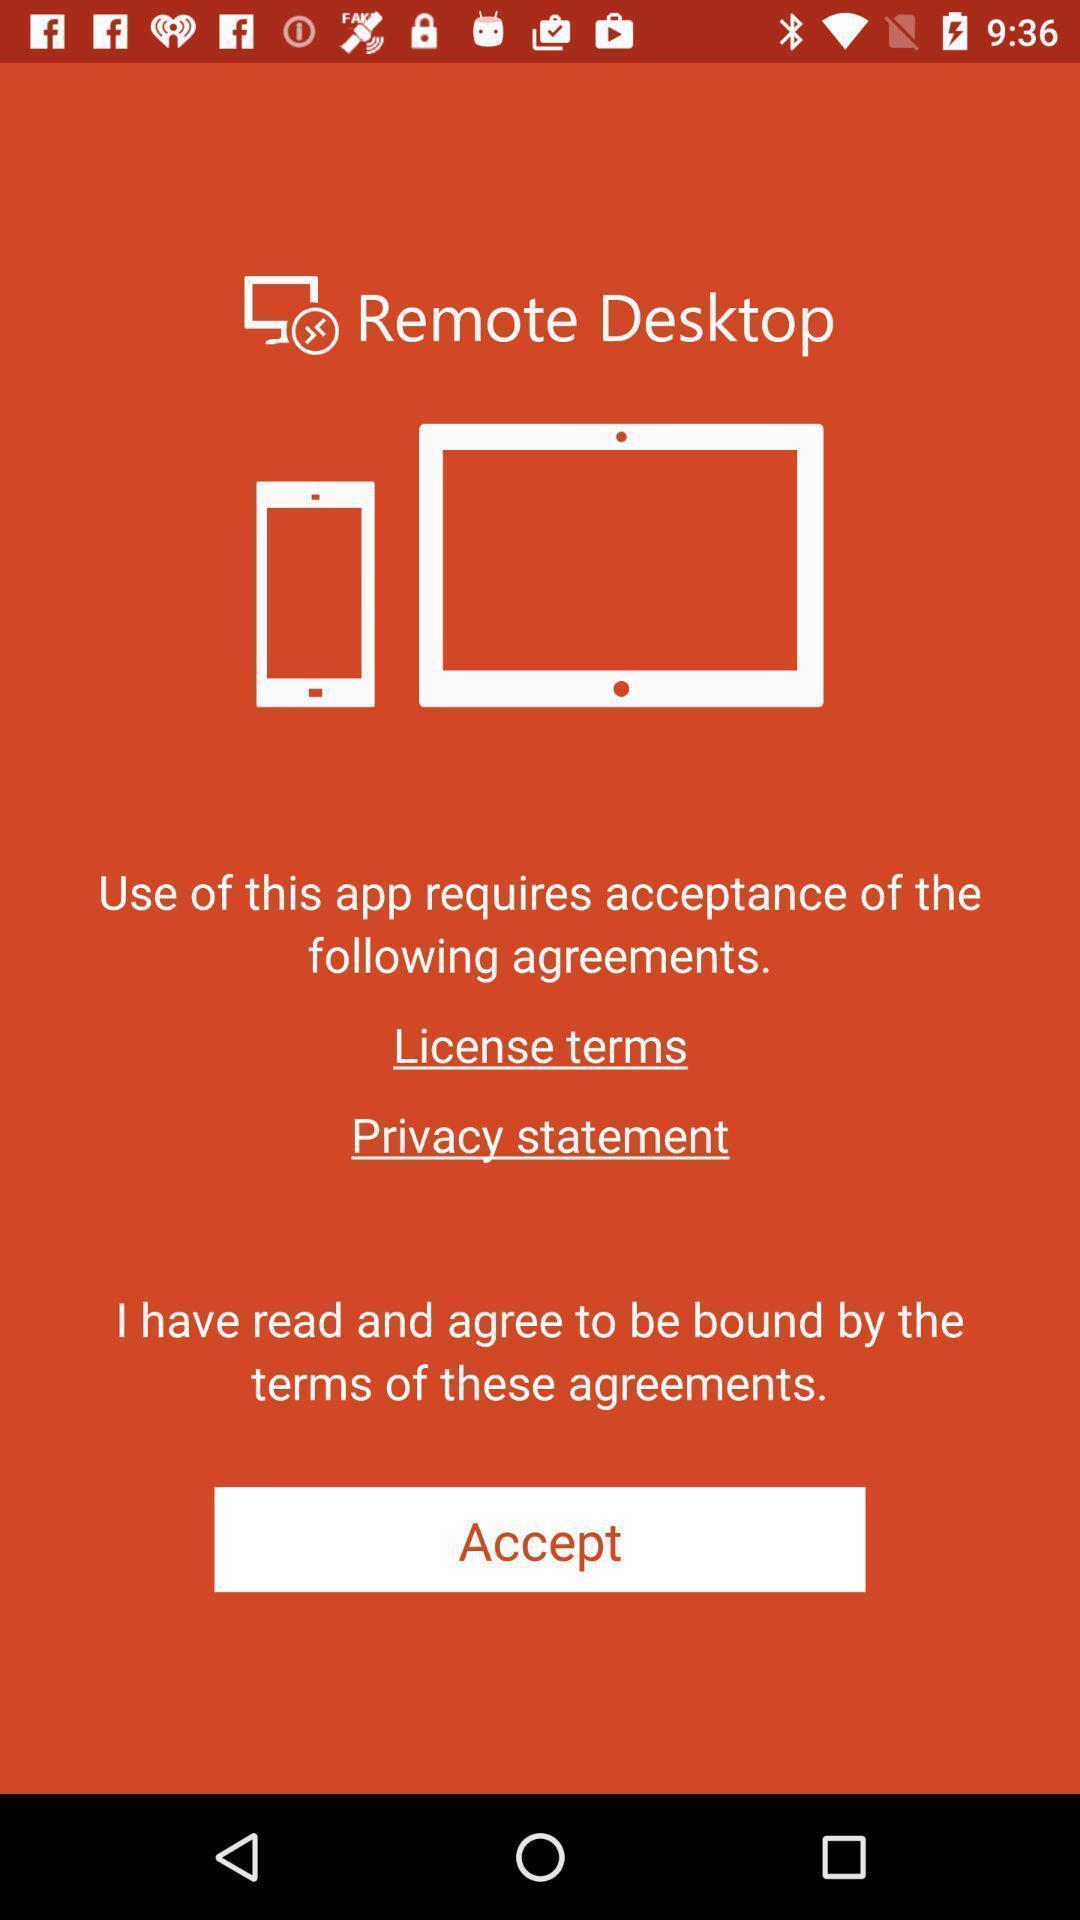Summarize the main components in this picture. Privacy policy page. 